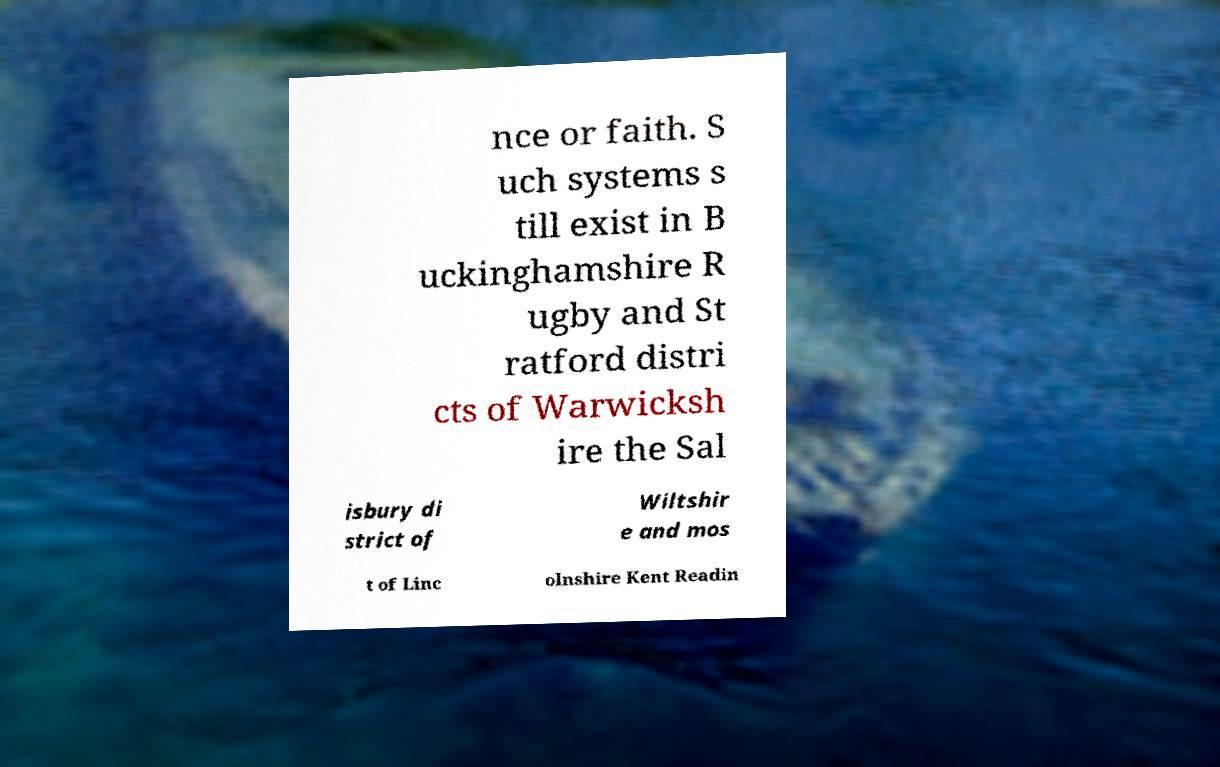Could you assist in decoding the text presented in this image and type it out clearly? nce or faith. S uch systems s till exist in B uckinghamshire R ugby and St ratford distri cts of Warwicksh ire the Sal isbury di strict of Wiltshir e and mos t of Linc olnshire Kent Readin 